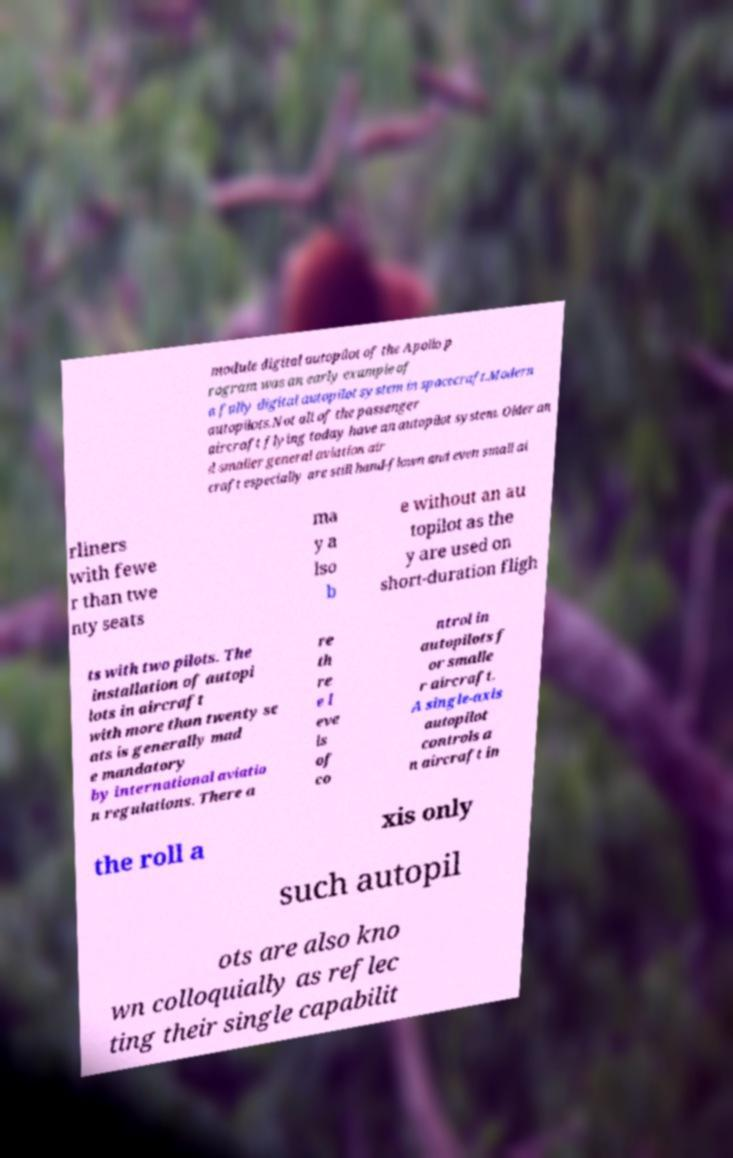For documentation purposes, I need the text within this image transcribed. Could you provide that? module digital autopilot of the Apollo p rogram was an early example of a fully digital autopilot system in spacecraft.Modern autopilots.Not all of the passenger aircraft flying today have an autopilot system. Older an d smaller general aviation air craft especially are still hand-flown and even small ai rliners with fewe r than twe nty seats ma y a lso b e without an au topilot as the y are used on short-duration fligh ts with two pilots. The installation of autopi lots in aircraft with more than twenty se ats is generally mad e mandatory by international aviatio n regulations. There a re th re e l eve ls of co ntrol in autopilots f or smalle r aircraft. A single-axis autopilot controls a n aircraft in the roll a xis only such autopil ots are also kno wn colloquially as reflec ting their single capabilit 